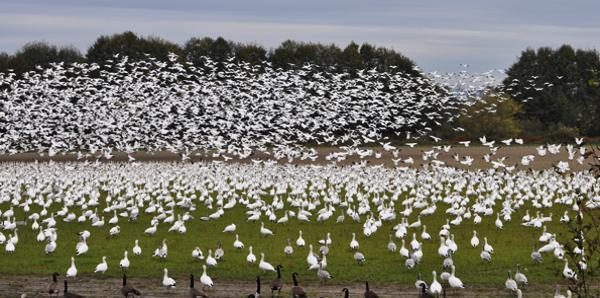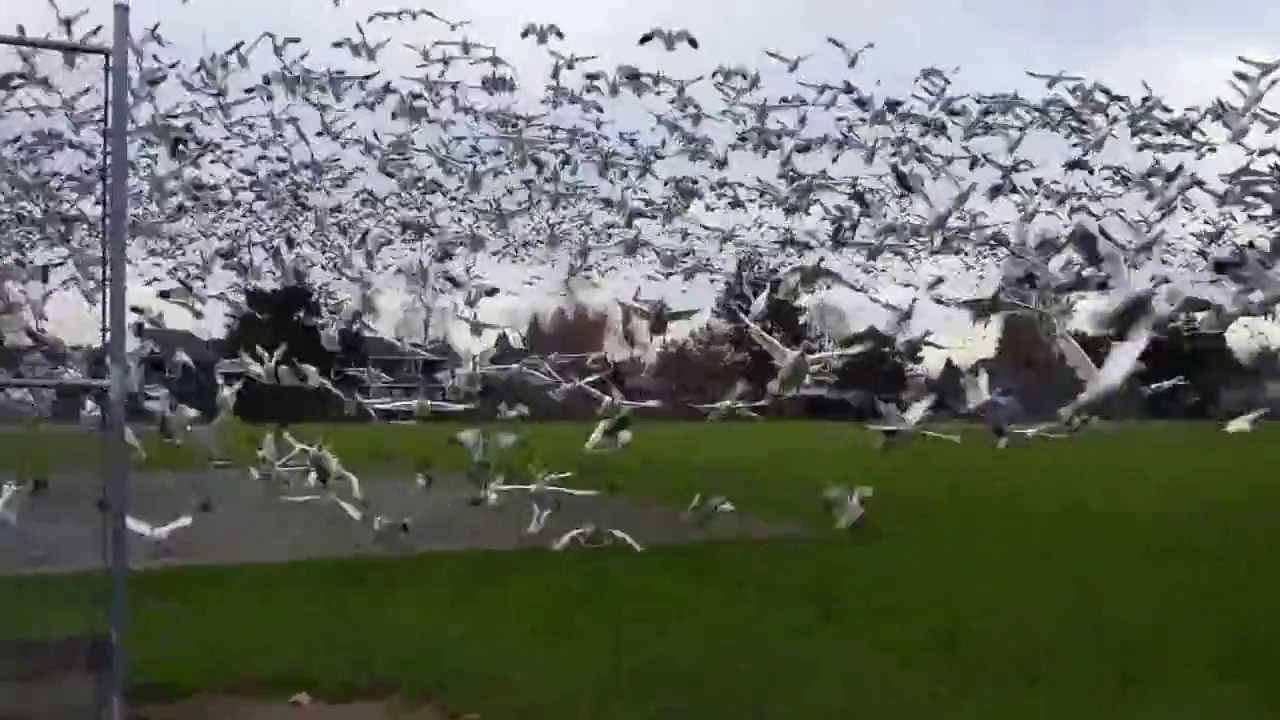The first image is the image on the left, the second image is the image on the right. Examine the images to the left and right. Is the description "Some of the birds in the image on the left are flying in the air." accurate? Answer yes or no. Yes. The first image is the image on the left, the second image is the image on the right. Assess this claim about the two images: "All birds are flying in the sky above a green field in one image.". Correct or not? Answer yes or no. Yes. 